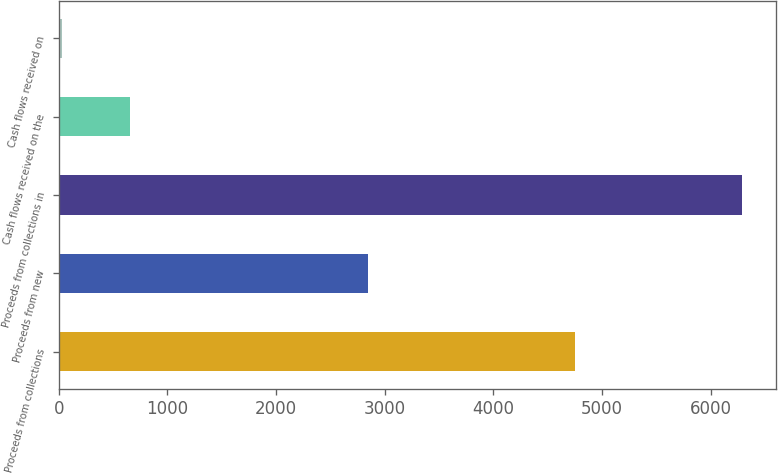Convert chart to OTSL. <chart><loc_0><loc_0><loc_500><loc_500><bar_chart><fcel>Proceeds from collections<fcel>Proceeds from new<fcel>Proceeds from collections in<fcel>Cash flows received on the<fcel>Cash flows received on<nl><fcel>4748.1<fcel>2844.4<fcel>6290.6<fcel>655.52<fcel>29.4<nl></chart> 